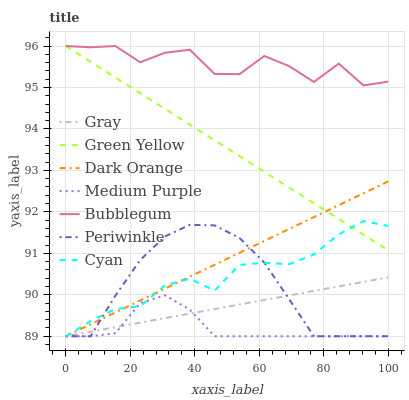Does Dark Orange have the minimum area under the curve?
Answer yes or no. No. Does Dark Orange have the maximum area under the curve?
Answer yes or no. No. Is Dark Orange the smoothest?
Answer yes or no. No. Is Dark Orange the roughest?
Answer yes or no. No. Does Bubblegum have the lowest value?
Answer yes or no. No. Does Dark Orange have the highest value?
Answer yes or no. No. Is Dark Orange less than Bubblegum?
Answer yes or no. Yes. Is Bubblegum greater than Medium Purple?
Answer yes or no. Yes. Does Dark Orange intersect Bubblegum?
Answer yes or no. No. 